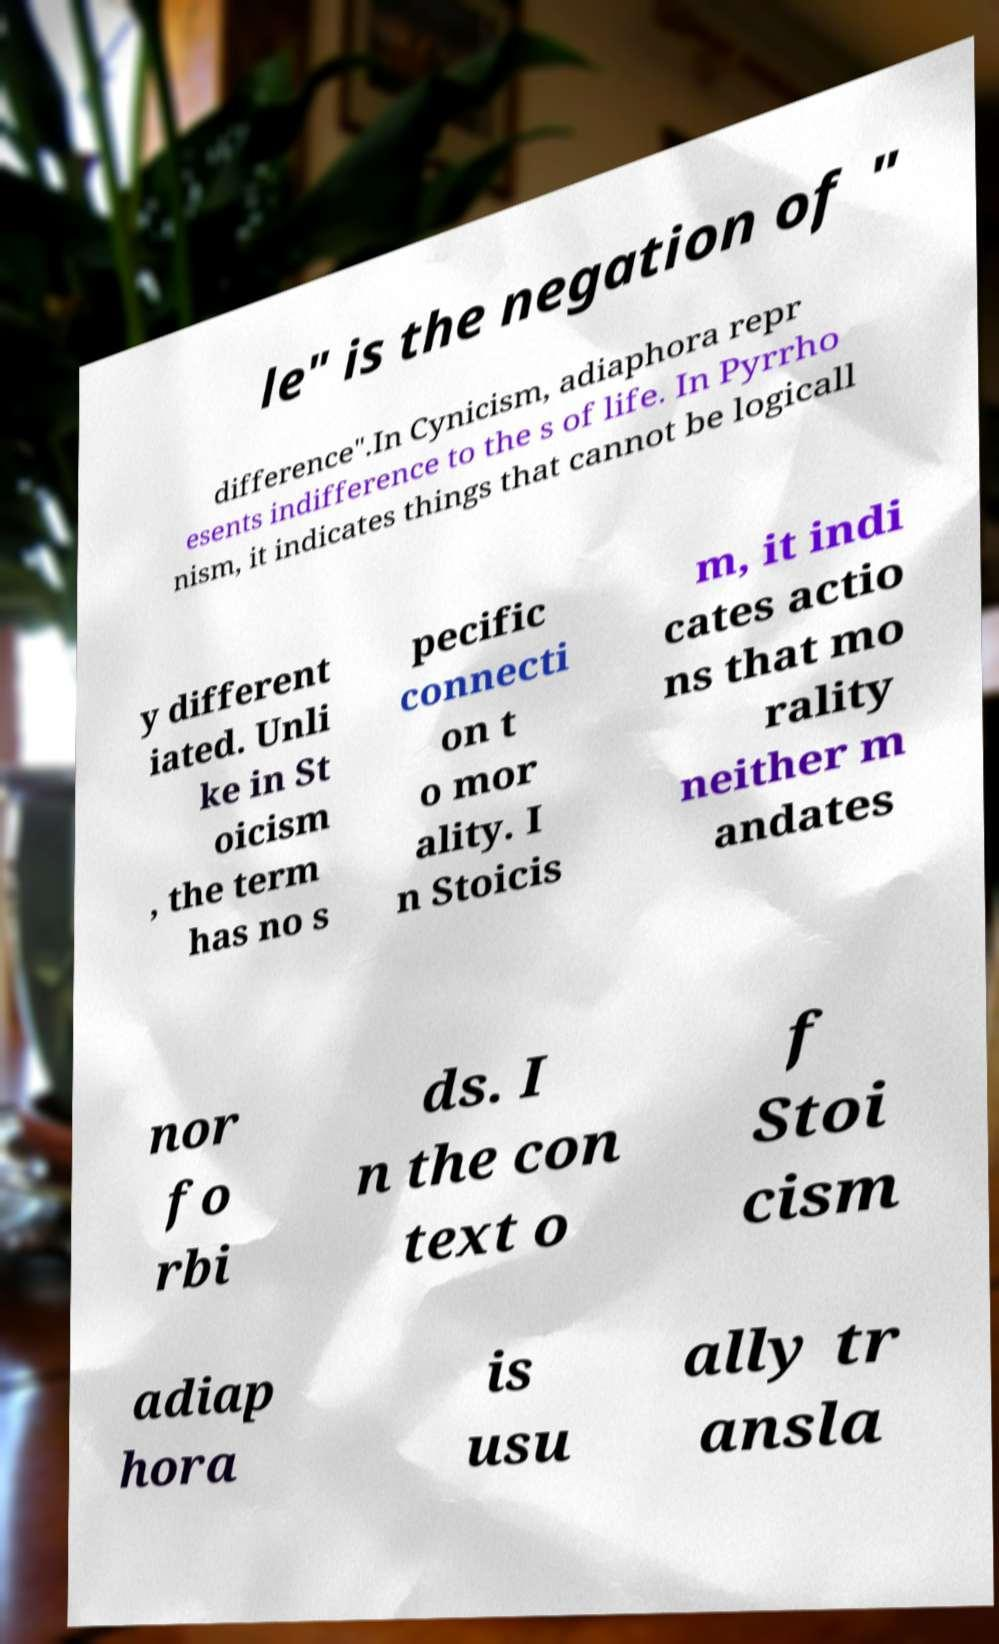What messages or text are displayed in this image? I need them in a readable, typed format. le" is the negation of " difference".In Cynicism, adiaphora repr esents indifference to the s of life. In Pyrrho nism, it indicates things that cannot be logicall y different iated. Unli ke in St oicism , the term has no s pecific connecti on t o mor ality. I n Stoicis m, it indi cates actio ns that mo rality neither m andates nor fo rbi ds. I n the con text o f Stoi cism adiap hora is usu ally tr ansla 